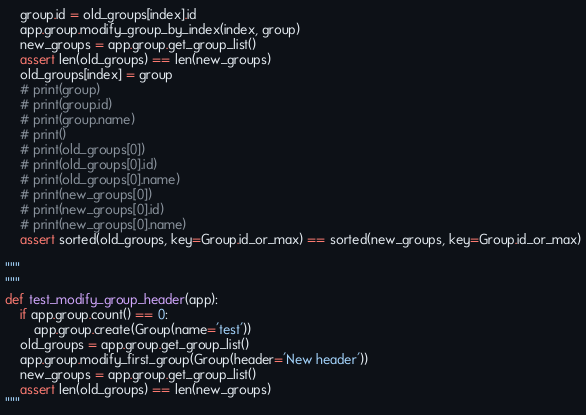Convert code to text. <code><loc_0><loc_0><loc_500><loc_500><_Python_>    group.id = old_groups[index].id
    app.group.modify_group_by_index(index, group)
    new_groups = app.group.get_group_list()
    assert len(old_groups) == len(new_groups)
    old_groups[index] = group
    # print(group)
    # print(group.id)
    # print(group.name)
    # print()
    # print(old_groups[0])
    # print(old_groups[0].id)
    # print(old_groups[0].name)
    # print(new_groups[0])
    # print(new_groups[0].id)
    # print(new_groups[0].name)
    assert sorted(old_groups, key=Group.id_or_max) == sorted(new_groups, key=Group.id_or_max)

"""
"""
def test_modify_group_header(app):
    if app.group.count() == 0:
        app.group.create(Group(name='test'))
    old_groups = app.group.get_group_list()
    app.group.modify_first_group(Group(header='New header'))
    new_groups = app.group.get_group_list()
    assert len(old_groups) == len(new_groups)
"""

</code> 